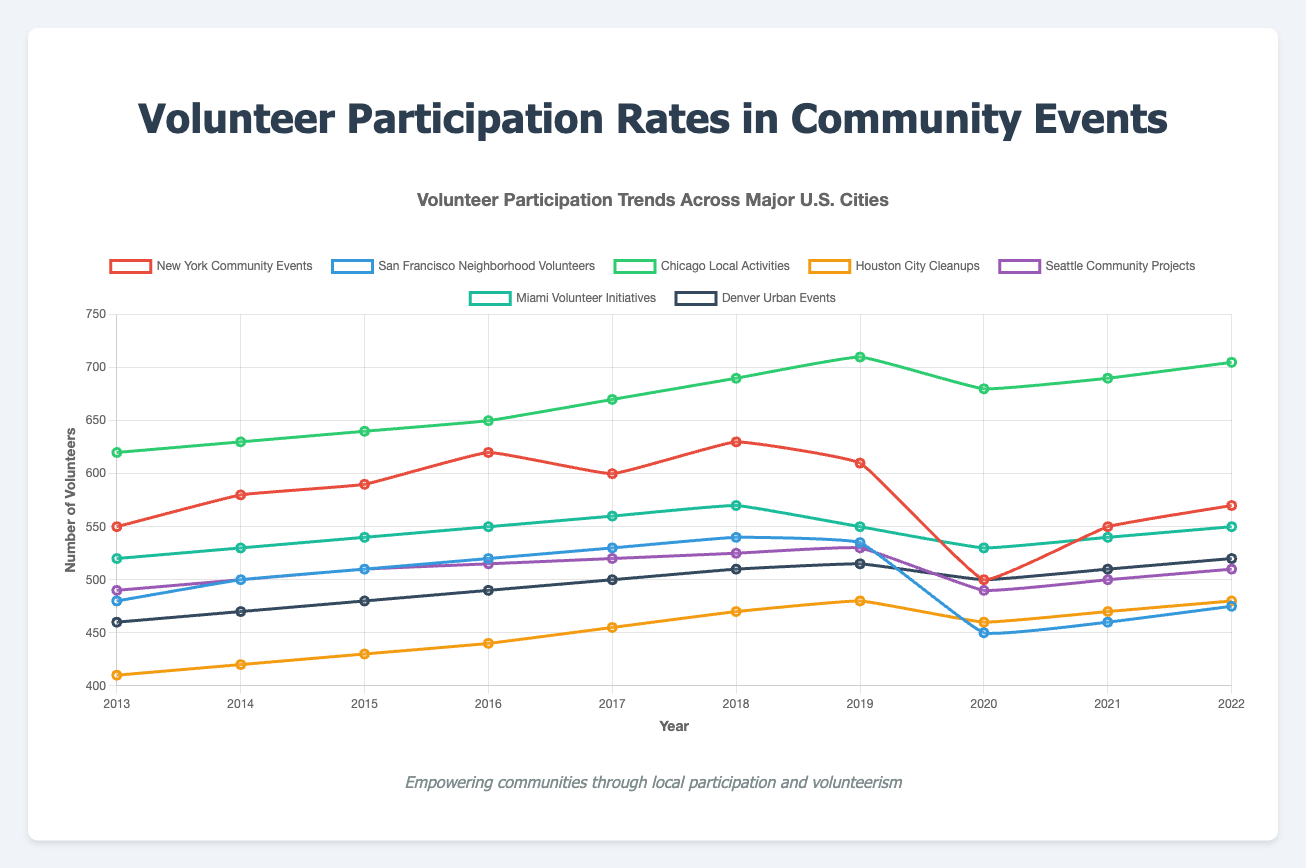Which city had the highest volunteer participation in 2022? In 2022, Chicago Local Activities had the highest participation rate as evidenced by the highest point on the line plot in that year.
Answer: Chicago Between 2013 and 2022, which city showed the most significant drop in volunteer participation? To determine the most significant drop, we look at the difference between the values in 2013 and 2022 for each city. San Francisco's Neighborhood Volunteers went from 480 to 475, New York from 550 to 570, etc. The largest negative difference is for San Francisco, which dropped from 540 to 450 in 2020, then slowly recovered but still below its peak.
Answer: San Francisco What was the average volunteer participation for Miami Volunteer Initiatives from 2013 to 2022? Sum all the values from Miami Volunteer Initiatives: 520 + 530 + 540 + 550 + 560 + 570 + 550 + 530 + 540 + 550 = 5440. Divide this sum by the number of years (10): 5440 / 10 = 544.
Answer: 544 In which year did Houston City Cleanups experience the highest volunteer participation, and what was the value? The highest point on the Houston City Cleanups line is in the year 2022 with a value of 480.
Answer: 2022, 480 How did volunteer participation in Denver Urban Events change between 2020 and 2021? In 2020, Denver Urban Events had 500 volunteers. In 2021, it increased to 510. The change in participation is 510 - 500 = 10.
Answer: Increased by 10 Compare the volunteer participation trend between Seattle Community Projects and Houston City Cleanups over the decade. Which city had a more consistent increase in participation? Seattle Community Projects and Houston City Cleanups both show an overall upward trend. However, Houston City Cleanups had a gentler, more steady rise each year, except for minor fluctuations, while Seattle had a drop in 2020.
Answer: Houston What is the median volunteer participation rate in New York Community Events over the years? Arrange the data values of New York Community Events in ascending order: 500, 550, 550, 570, 580, 590, 600, 610, 620, 630. Since there are 10 values, find the average of the 5th and 6th values: (580 + 590) / 2 = 585.
Answer: 585 Compare the volunteer participation in Chicago Local Activities and New York Community Events in 2018. Which city had a higher participation rate? In 2018, Chicago Local Activities had 690 volunteers, while New York Community Events had 630. Therefore, Chicago had a higher rate.
Answer: Chicago Which city experienced the biggest drop in volunteer participation during the COVID-19 pandemic period (2020)? Examine the data between 2019 and 2020. San Francisco Neighborhood Volunteers saw the biggest drop from 535 in 2019 to 450 in 2020, a decrease of 85 volunteers.
Answer: San Francisco How many times did Miami Volunteer Initiatives see an increase in volunteer participation from one year to the next between 2013 and 2022? Count the yearly increments in Miami Volunteer Initiatives' data: 2014, 2015, 2016, 2017, 2018, 2021, 2022. This gives 7 times.
Answer: 7 